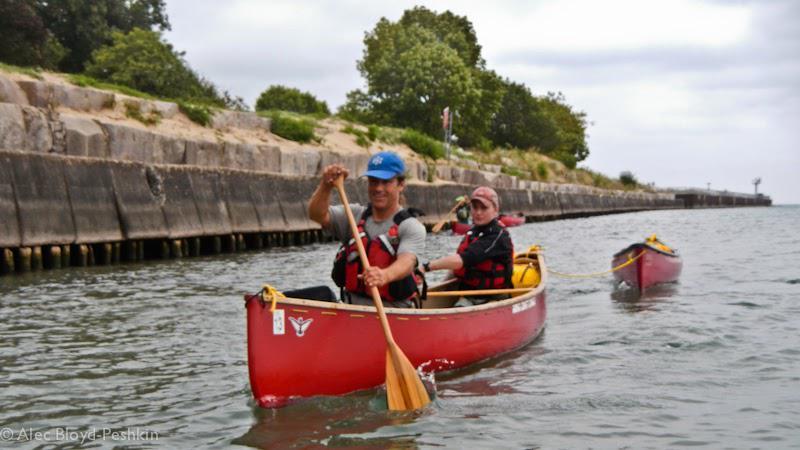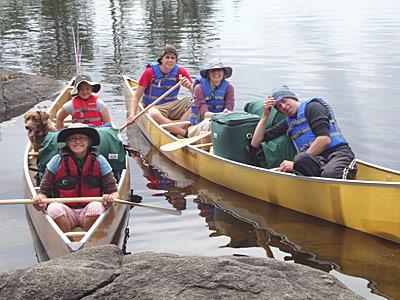The first image is the image on the left, the second image is the image on the right. Considering the images on both sides, is "One image shows people standing along one side of a canoe instead of sitting in it." valid? Answer yes or no. No. The first image is the image on the left, the second image is the image on the right. Assess this claim about the two images: "In at least one of the images, people are shown outside of the canoe.". Correct or not? Answer yes or no. No. 